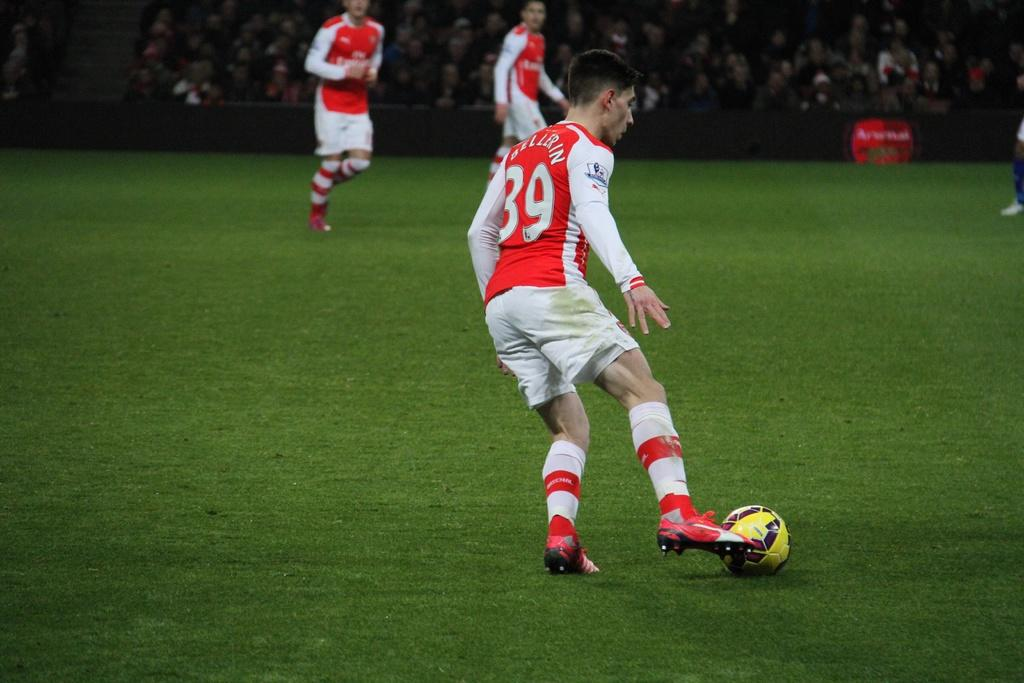Who or what can be seen in the image? There are people in the image. What is on the grass in the image? There is a ball on the grass. What type of surface is visible in the image? The grass is visible in the image. What can be seen in the background of the image? There is a group of people and an object in the background of the image. Where is the toothbrush located in the image? There is no toothbrush present in the image. What type of knowledge is being shared among the people in the image? The image does not provide any information about the knowledge being shared among the people. 